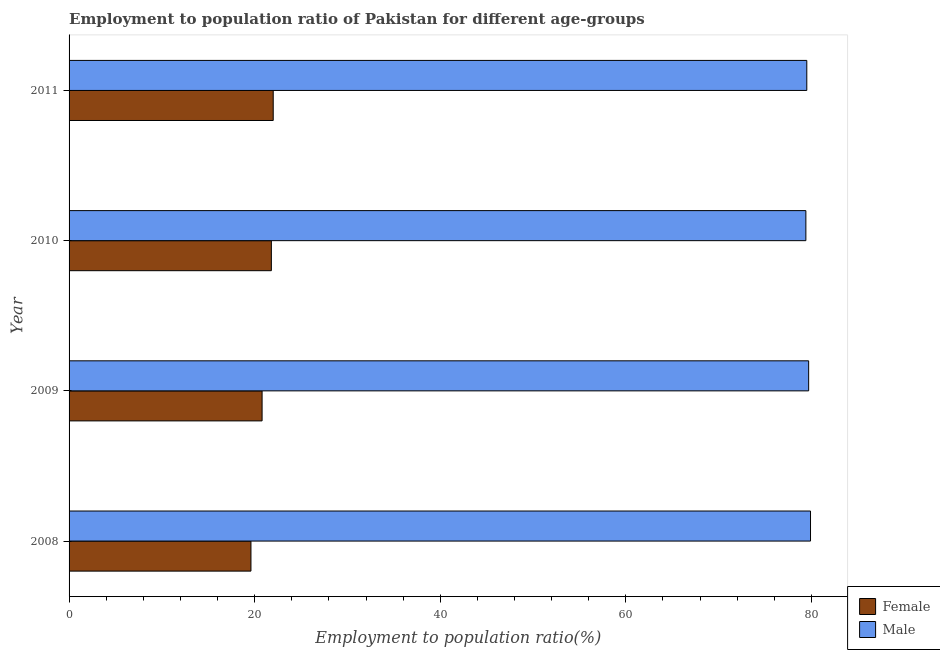How many different coloured bars are there?
Offer a terse response. 2. How many bars are there on the 1st tick from the top?
Provide a succinct answer. 2. How many bars are there on the 2nd tick from the bottom?
Provide a short and direct response. 2. What is the label of the 3rd group of bars from the top?
Your answer should be compact. 2009. In how many cases, is the number of bars for a given year not equal to the number of legend labels?
Offer a very short reply. 0. What is the employment to population ratio(male) in 2009?
Provide a short and direct response. 79.7. Across all years, what is the minimum employment to population ratio(male)?
Make the answer very short. 79.4. What is the total employment to population ratio(female) in the graph?
Keep it short and to the point. 84.2. What is the difference between the employment to population ratio(female) in 2008 and that in 2010?
Provide a succinct answer. -2.2. What is the difference between the employment to population ratio(male) in 2009 and the employment to population ratio(female) in 2011?
Make the answer very short. 57.7. What is the average employment to population ratio(female) per year?
Make the answer very short. 21.05. In the year 2009, what is the difference between the employment to population ratio(female) and employment to population ratio(male)?
Ensure brevity in your answer.  -58.9. What is the ratio of the employment to population ratio(female) in 2009 to that in 2010?
Provide a short and direct response. 0.95. In how many years, is the employment to population ratio(male) greater than the average employment to population ratio(male) taken over all years?
Your answer should be compact. 2. What does the 1st bar from the top in 2008 represents?
Make the answer very short. Male. What does the 1st bar from the bottom in 2010 represents?
Give a very brief answer. Female. How many years are there in the graph?
Give a very brief answer. 4. Does the graph contain grids?
Your answer should be very brief. No. How many legend labels are there?
Keep it short and to the point. 2. How are the legend labels stacked?
Give a very brief answer. Vertical. What is the title of the graph?
Give a very brief answer. Employment to population ratio of Pakistan for different age-groups. Does "Resident" appear as one of the legend labels in the graph?
Your answer should be compact. No. What is the label or title of the X-axis?
Ensure brevity in your answer.  Employment to population ratio(%). What is the Employment to population ratio(%) in Female in 2008?
Give a very brief answer. 19.6. What is the Employment to population ratio(%) of Male in 2008?
Make the answer very short. 79.9. What is the Employment to population ratio(%) of Female in 2009?
Offer a terse response. 20.8. What is the Employment to population ratio(%) in Male in 2009?
Your answer should be very brief. 79.7. What is the Employment to population ratio(%) of Female in 2010?
Offer a very short reply. 21.8. What is the Employment to population ratio(%) in Male in 2010?
Your answer should be very brief. 79.4. What is the Employment to population ratio(%) of Female in 2011?
Make the answer very short. 22. What is the Employment to population ratio(%) of Male in 2011?
Offer a terse response. 79.5. Across all years, what is the maximum Employment to population ratio(%) of Female?
Provide a succinct answer. 22. Across all years, what is the maximum Employment to population ratio(%) of Male?
Give a very brief answer. 79.9. Across all years, what is the minimum Employment to population ratio(%) in Female?
Your answer should be compact. 19.6. Across all years, what is the minimum Employment to population ratio(%) of Male?
Your answer should be compact. 79.4. What is the total Employment to population ratio(%) in Female in the graph?
Offer a very short reply. 84.2. What is the total Employment to population ratio(%) in Male in the graph?
Provide a succinct answer. 318.5. What is the difference between the Employment to population ratio(%) of Female in 2008 and that in 2009?
Give a very brief answer. -1.2. What is the difference between the Employment to population ratio(%) of Female in 2008 and that in 2010?
Provide a short and direct response. -2.2. What is the difference between the Employment to population ratio(%) in Female in 2009 and that in 2010?
Give a very brief answer. -1. What is the difference between the Employment to population ratio(%) in Male in 2009 and that in 2010?
Keep it short and to the point. 0.3. What is the difference between the Employment to population ratio(%) of Male in 2009 and that in 2011?
Make the answer very short. 0.2. What is the difference between the Employment to population ratio(%) in Female in 2010 and that in 2011?
Your answer should be very brief. -0.2. What is the difference between the Employment to population ratio(%) in Female in 2008 and the Employment to population ratio(%) in Male in 2009?
Provide a succinct answer. -60.1. What is the difference between the Employment to population ratio(%) of Female in 2008 and the Employment to population ratio(%) of Male in 2010?
Ensure brevity in your answer.  -59.8. What is the difference between the Employment to population ratio(%) in Female in 2008 and the Employment to population ratio(%) in Male in 2011?
Offer a very short reply. -59.9. What is the difference between the Employment to population ratio(%) in Female in 2009 and the Employment to population ratio(%) in Male in 2010?
Make the answer very short. -58.6. What is the difference between the Employment to population ratio(%) in Female in 2009 and the Employment to population ratio(%) in Male in 2011?
Your answer should be compact. -58.7. What is the difference between the Employment to population ratio(%) of Female in 2010 and the Employment to population ratio(%) of Male in 2011?
Your answer should be very brief. -57.7. What is the average Employment to population ratio(%) of Female per year?
Your response must be concise. 21.05. What is the average Employment to population ratio(%) in Male per year?
Provide a short and direct response. 79.62. In the year 2008, what is the difference between the Employment to population ratio(%) in Female and Employment to population ratio(%) in Male?
Your answer should be very brief. -60.3. In the year 2009, what is the difference between the Employment to population ratio(%) in Female and Employment to population ratio(%) in Male?
Give a very brief answer. -58.9. In the year 2010, what is the difference between the Employment to population ratio(%) of Female and Employment to population ratio(%) of Male?
Provide a short and direct response. -57.6. In the year 2011, what is the difference between the Employment to population ratio(%) of Female and Employment to population ratio(%) of Male?
Give a very brief answer. -57.5. What is the ratio of the Employment to population ratio(%) in Female in 2008 to that in 2009?
Keep it short and to the point. 0.94. What is the ratio of the Employment to population ratio(%) in Female in 2008 to that in 2010?
Offer a terse response. 0.9. What is the ratio of the Employment to population ratio(%) in Female in 2008 to that in 2011?
Offer a terse response. 0.89. What is the ratio of the Employment to population ratio(%) in Female in 2009 to that in 2010?
Your answer should be compact. 0.95. What is the ratio of the Employment to population ratio(%) in Female in 2009 to that in 2011?
Give a very brief answer. 0.95. What is the ratio of the Employment to population ratio(%) in Female in 2010 to that in 2011?
Offer a very short reply. 0.99. What is the ratio of the Employment to population ratio(%) in Male in 2010 to that in 2011?
Make the answer very short. 1. What is the difference between the highest and the second highest Employment to population ratio(%) in Female?
Your answer should be very brief. 0.2. What is the difference between the highest and the second highest Employment to population ratio(%) of Male?
Offer a very short reply. 0.2. What is the difference between the highest and the lowest Employment to population ratio(%) of Male?
Offer a terse response. 0.5. 